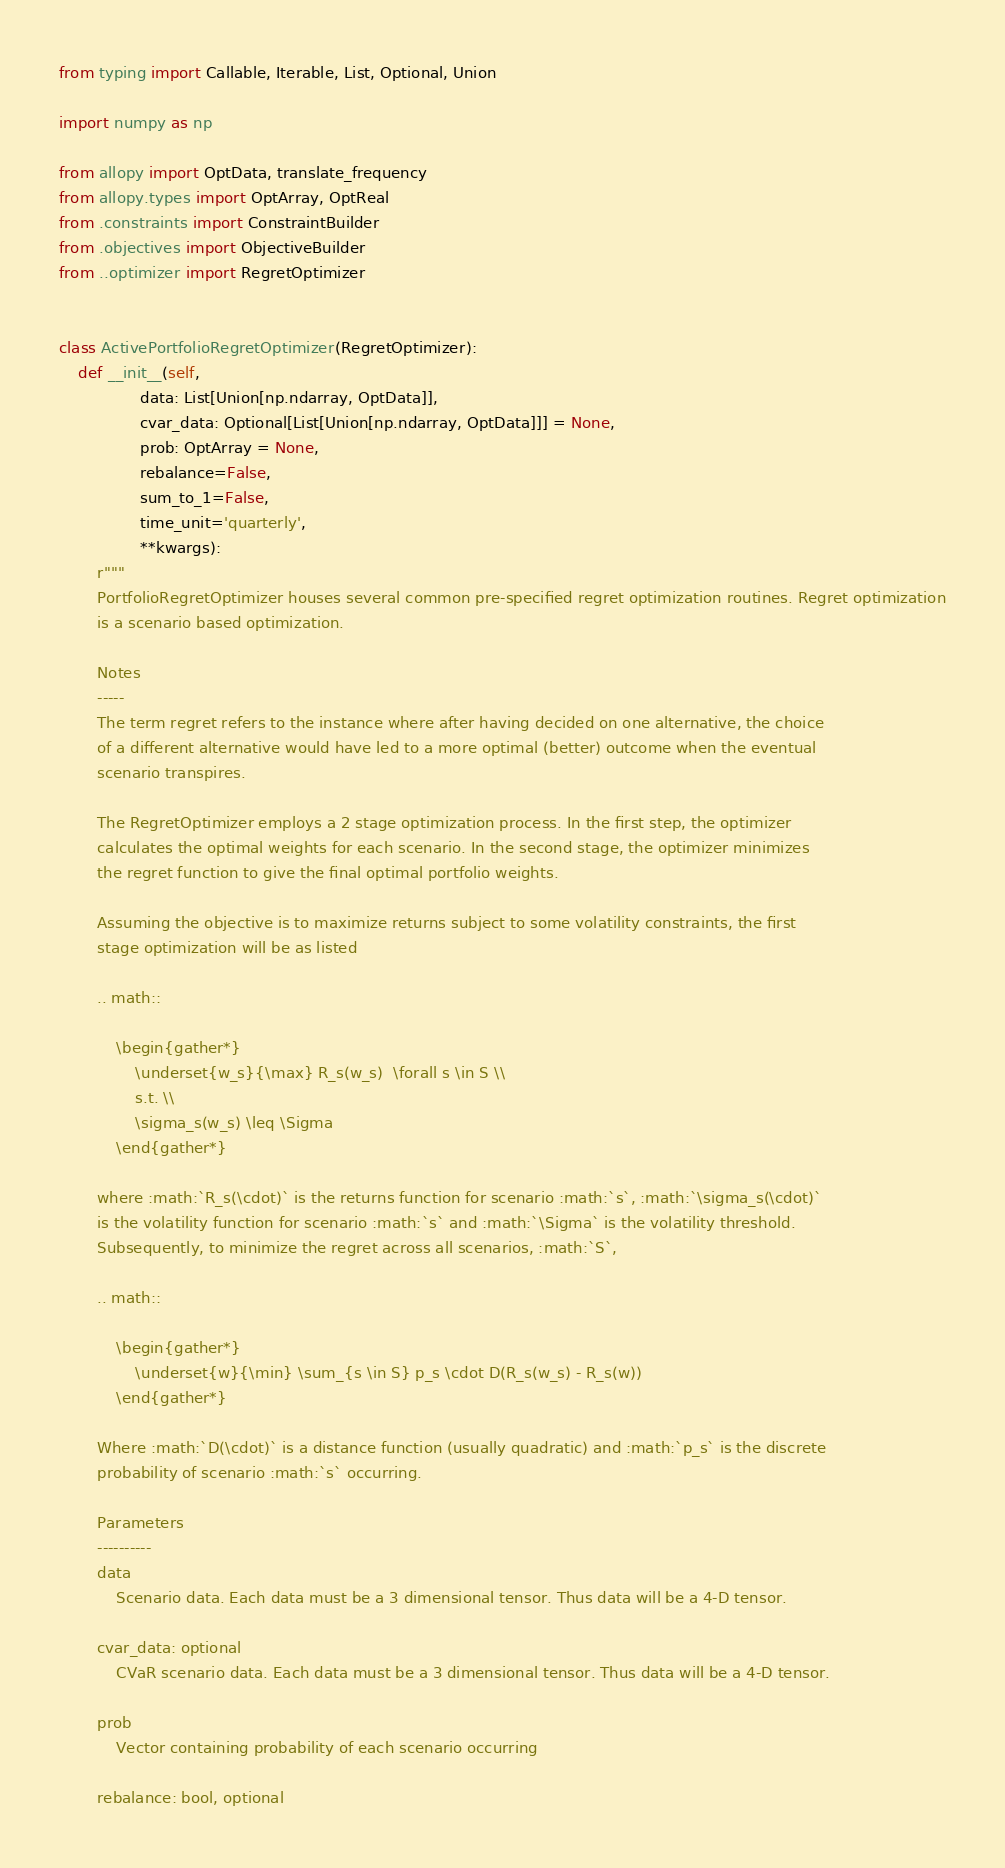<code> <loc_0><loc_0><loc_500><loc_500><_Python_>from typing import Callable, Iterable, List, Optional, Union

import numpy as np

from allopy import OptData, translate_frequency
from allopy.types import OptArray, OptReal
from .constraints import ConstraintBuilder
from .objectives import ObjectiveBuilder
from ..optimizer import RegretOptimizer


class ActivePortfolioRegretOptimizer(RegretOptimizer):
    def __init__(self,
                 data: List[Union[np.ndarray, OptData]],
                 cvar_data: Optional[List[Union[np.ndarray, OptData]]] = None,
                 prob: OptArray = None,
                 rebalance=False,
                 sum_to_1=False,
                 time_unit='quarterly',
                 **kwargs):
        r"""
        PortfolioRegretOptimizer houses several common pre-specified regret optimization routines. Regret optimization
        is a scenario based optimization.

        Notes
        -----
        The term regret refers to the instance where after having decided on one alternative, the choice
        of a different alternative would have led to a more optimal (better) outcome when the eventual
        scenario transpires.

        The RegretOptimizer employs a 2 stage optimization process. In the first step, the optimizer
        calculates the optimal weights for each scenario. In the second stage, the optimizer minimizes
        the regret function to give the final optimal portfolio weights.

        Assuming the objective is to maximize returns subject to some volatility constraints, the first
        stage optimization will be as listed

        .. math::

            \begin{gather*}
                \underset{w_s}{\max} R_s(w_s)  \forall s \in S \\
                s.t. \\
                \sigma_s(w_s) \leq \Sigma
            \end{gather*}

        where :math:`R_s(\cdot)` is the returns function for scenario :math:`s`, :math:`\sigma_s(\cdot)`
        is the volatility function for scenario :math:`s` and :math:`\Sigma` is the volatility threshold.
        Subsequently, to minimize the regret across all scenarios, :math:`S`,

        .. math::

            \begin{gather*}
                \underset{w}{\min} \sum_{s \in S} p_s \cdot D(R_s(w_s) - R_s(w))
            \end{gather*}

        Where :math:`D(\cdot)` is a distance function (usually quadratic) and :math:`p_s` is the discrete
        probability of scenario :math:`s` occurring.

        Parameters
        ----------
        data
            Scenario data. Each data must be a 3 dimensional tensor. Thus data will be a 4-D tensor.

        cvar_data: optional
            CVaR scenario data. Each data must be a 3 dimensional tensor. Thus data will be a 4-D tensor.

        prob
            Vector containing probability of each scenario occurring

        rebalance: bool, optional</code> 